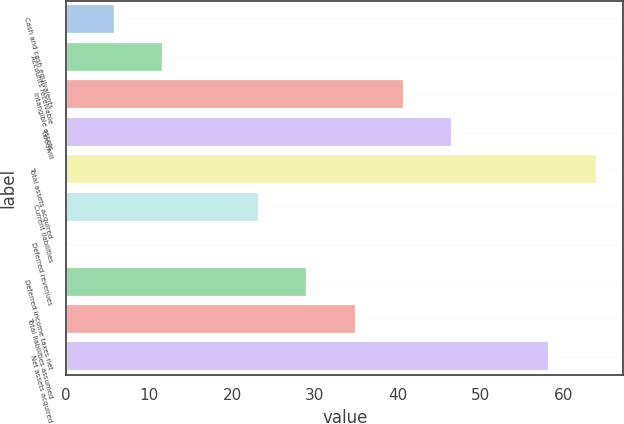<chart> <loc_0><loc_0><loc_500><loc_500><bar_chart><fcel>Cash and cash equivalents<fcel>Accounts receivable<fcel>Intangible assets<fcel>Goodwill<fcel>Total assets acquired<fcel>Current liabilities<fcel>Deferred revenues<fcel>Deferred income taxes net<fcel>Total liabilities assumed<fcel>Net assets acquired<nl><fcel>5.9<fcel>11.7<fcel>40.7<fcel>46.5<fcel>64<fcel>23.3<fcel>0.1<fcel>29.1<fcel>34.9<fcel>58.2<nl></chart> 